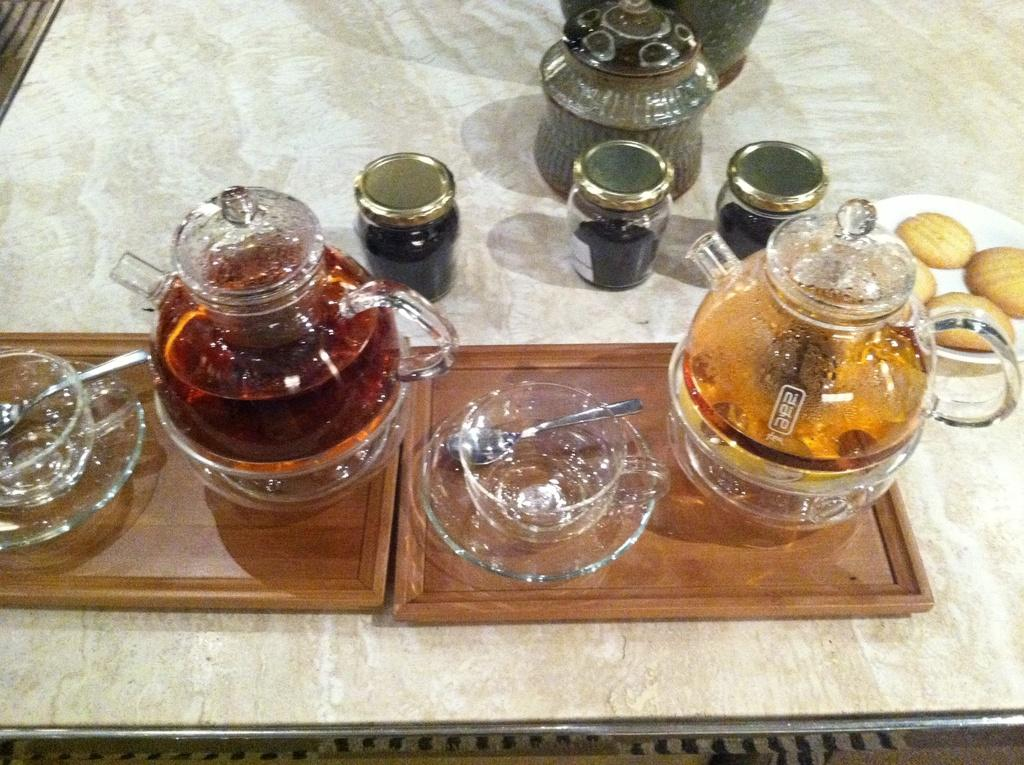What type of furniture is present in the image? There is a table in the image. What items can be found on the table? There are jars, a cup, saucers, trays, a plate, biscuits, and a vase on the table. What is inside the jars on the table? The jars contain honey. What type of food is present on the table? There are biscuits on the table. Can you see a cake being shared with a kiss in the image? There is no cake or kiss present in the image. Is there a thumb visible on the table in the image? There is no thumb visible on the table in the image. 